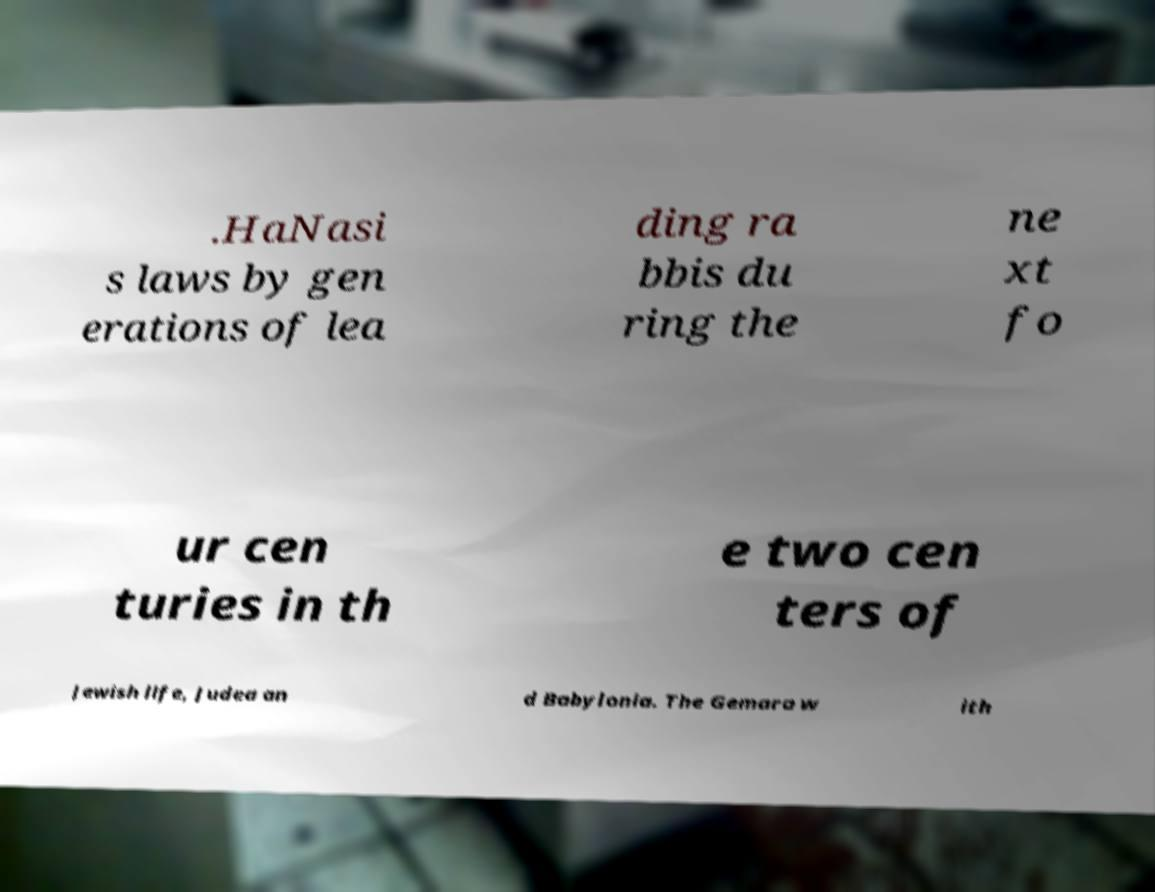Please identify and transcribe the text found in this image. .HaNasi s laws by gen erations of lea ding ra bbis du ring the ne xt fo ur cen turies in th e two cen ters of Jewish life, Judea an d Babylonia. The Gemara w ith 